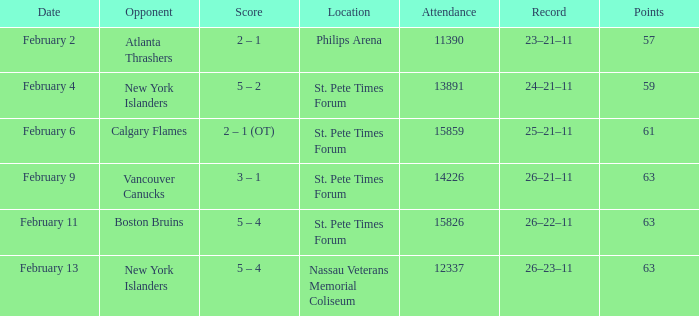Can you provide the scores from february 9? 3 – 1. 